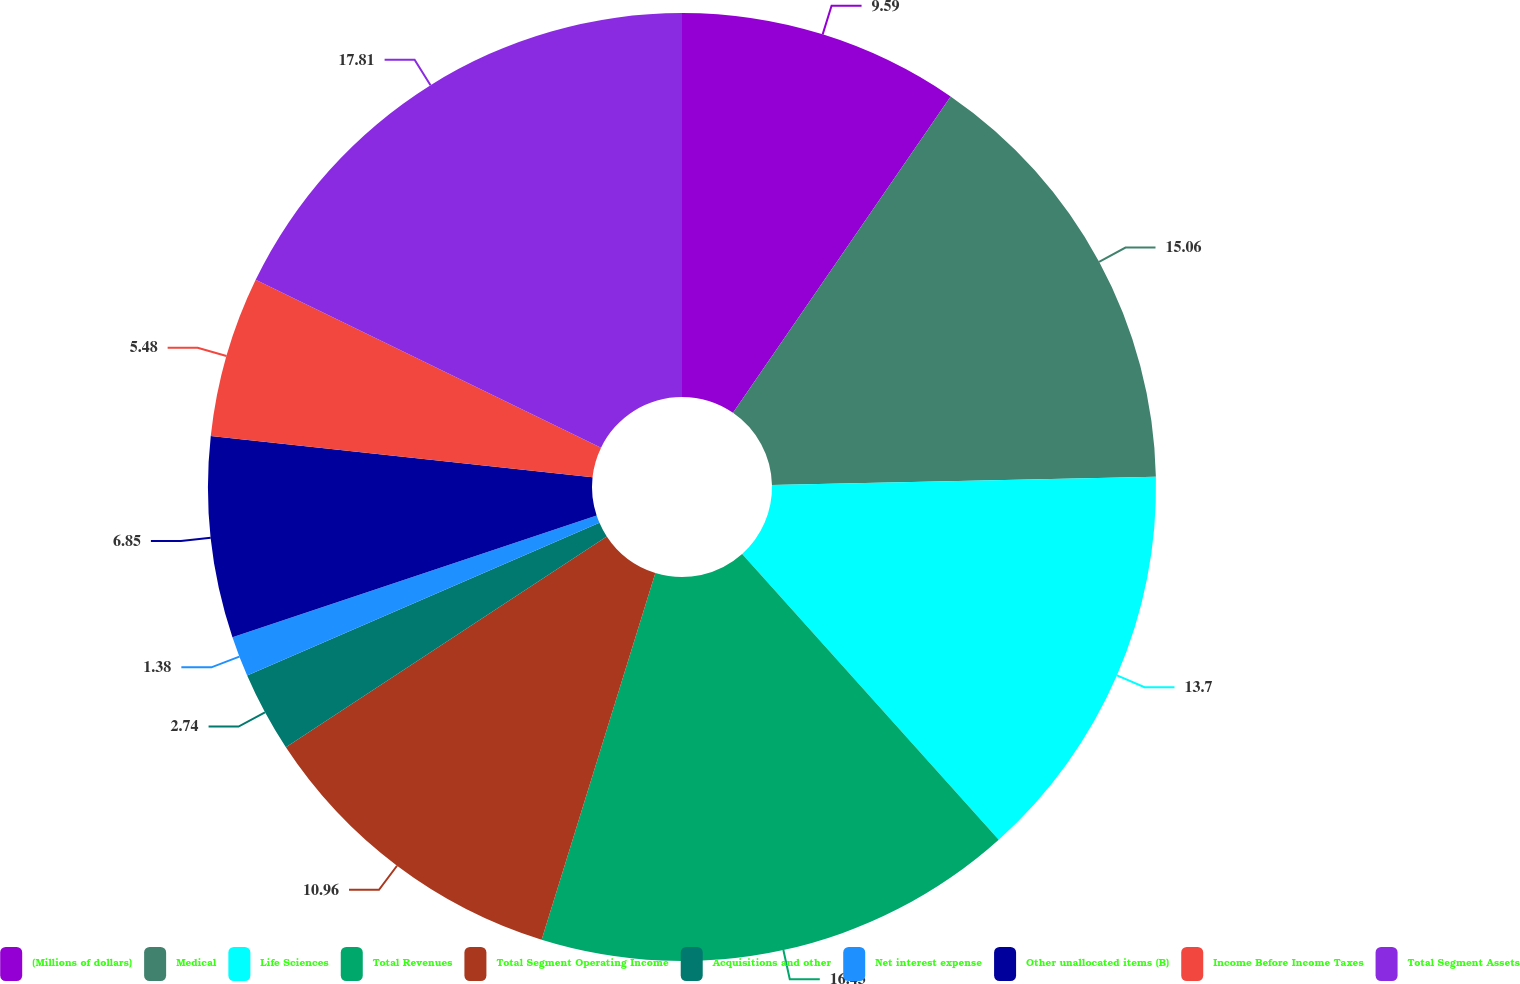Convert chart to OTSL. <chart><loc_0><loc_0><loc_500><loc_500><pie_chart><fcel>(Millions of dollars)<fcel>Medical<fcel>Life Sciences<fcel>Total Revenues<fcel>Total Segment Operating Income<fcel>Acquisitions and other<fcel>Net interest expense<fcel>Other unallocated items (B)<fcel>Income Before Income Taxes<fcel>Total Segment Assets<nl><fcel>9.59%<fcel>15.06%<fcel>13.7%<fcel>16.43%<fcel>10.96%<fcel>2.74%<fcel>1.38%<fcel>6.85%<fcel>5.48%<fcel>17.8%<nl></chart> 